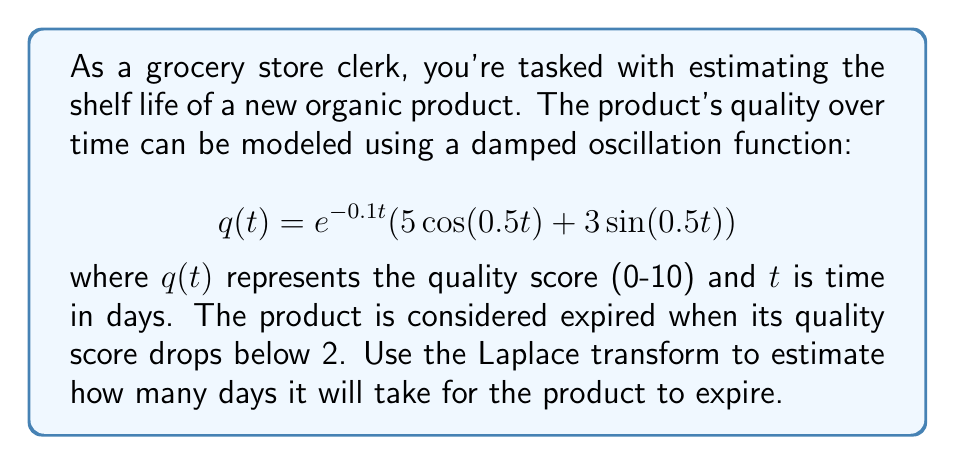Provide a solution to this math problem. To solve this problem, we'll use the following steps:

1) First, we need to find the Laplace transform of $q(t)$. Let's denote the Laplace transform as $Q(s)$.

   $$\mathcal{L}\{q(t)\} = Q(s) = \mathcal{L}\{e^{-0.1t}(5\cos(0.5t) + 3\sin(0.5t))\}$$

2) Using the property of Laplace transform for exponential functions and the linearity property:

   $$Q(s) = 5\mathcal{L}\{e^{-0.1t}\cos(0.5t)\} + 3\mathcal{L}\{e^{-0.1t}\sin(0.5t)\}$$

3) Applying the Laplace transform formulas for damped cosine and sine functions:

   $$Q(s) = 5\frac{s+0.1}{(s+0.1)^2 + 0.5^2} + 3\frac{0.5}{(s+0.1)^2 + 0.5^2}$$

4) Simplifying:

   $$Q(s) = \frac{5s + 0.5 + 1.5}{s^2 + 0.2s + 0.26} = \frac{5s + 2}{s^2 + 0.2s + 0.26}$$

5) To find when $q(t) = 2$, we need to solve:

   $$\mathcal{L}\{q(t) - 2\} = Q(s) - \frac{2}{s} = \frac{5s + 2}{s^2 + 0.2s + 0.26} - \frac{2}{s} = 0$$

6) Multiplying both sides by $s(s^2 + 0.2s + 0.26)$:

   $$(5s + 2)s - 2(s^2 + 0.2s + 0.26) = 0$$

7) Expanding:

   $$5s^2 + 2s - 2s^2 - 0.4s - 0.52 = 0$$
   $$3s^2 + 1.6s - 0.52 = 0$$

8) Solving this quadratic equation:

   $$s = \frac{-1.6 \pm \sqrt{1.6^2 + 4(3)(0.52)}}{2(3)} = \frac{-1.6 \pm \sqrt{8.64}}{6}$$

9) The positive root is approximately 0.2733. This is the real part of the complex frequency, which corresponds to the decay rate.

10) The time constant $\tau$ is the reciprocal of this value:

    $$\tau = \frac{1}{0.2733} \approx 3.66 \text{ days}$$

11) The product will expire after approximately 3-4 time constants, so we estimate 3.66 * 3.5 ≈ 12.81 days.
Answer: The estimated shelf life of the product is approximately 13 days. 